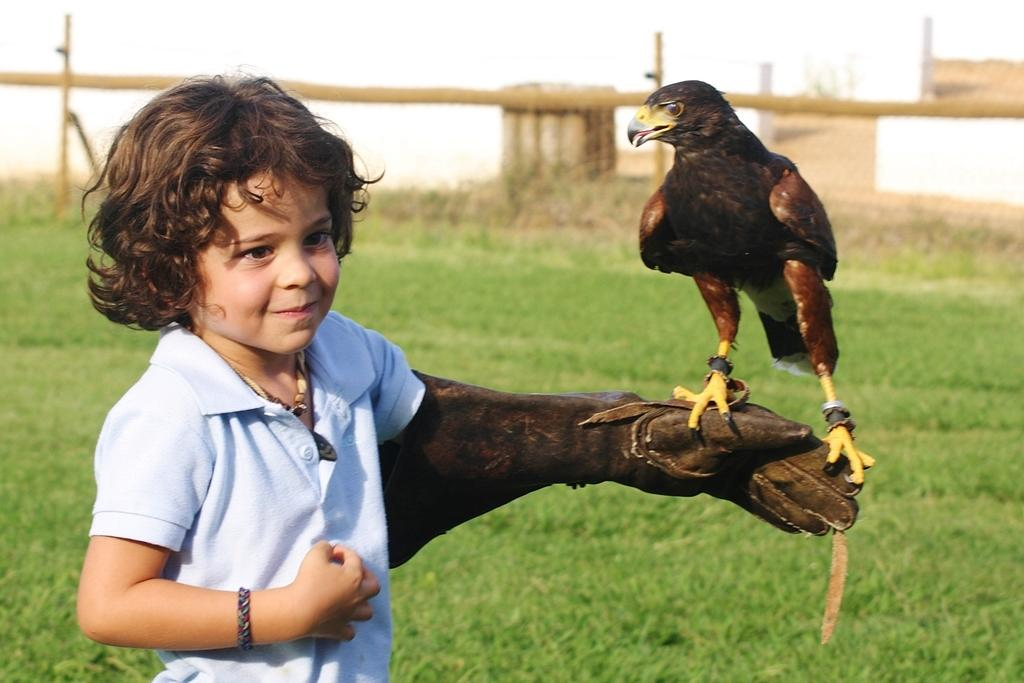Who is the main subject in the image? There is a boy in the image. What is the boy wearing? The boy is wearing a t-shirt. What is the boy holding in the image? There is an eagle on the boy's hand. What can be seen in the background of the image? There is grass and brown-colored objects visible in the background of the image. What type of spoon is being used to cast a spell in the image? There is no spoon or casting of spells present in the image. 